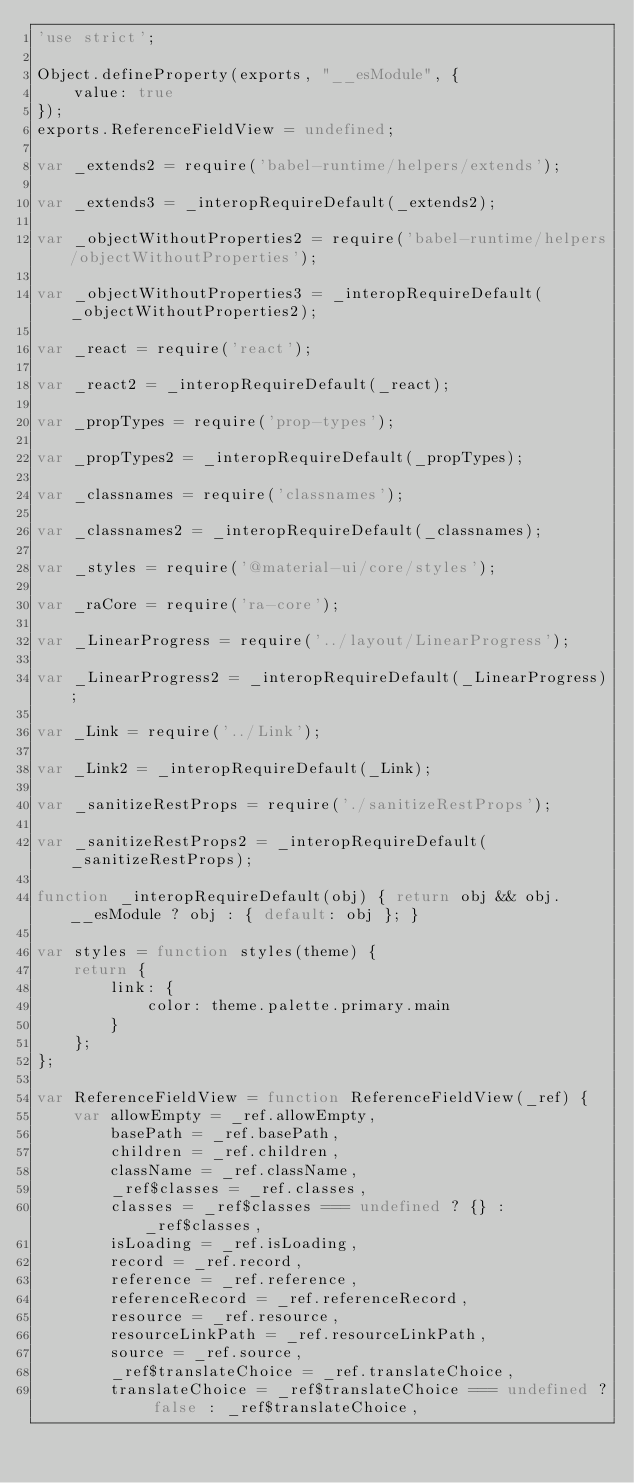Convert code to text. <code><loc_0><loc_0><loc_500><loc_500><_JavaScript_>'use strict';

Object.defineProperty(exports, "__esModule", {
    value: true
});
exports.ReferenceFieldView = undefined;

var _extends2 = require('babel-runtime/helpers/extends');

var _extends3 = _interopRequireDefault(_extends2);

var _objectWithoutProperties2 = require('babel-runtime/helpers/objectWithoutProperties');

var _objectWithoutProperties3 = _interopRequireDefault(_objectWithoutProperties2);

var _react = require('react');

var _react2 = _interopRequireDefault(_react);

var _propTypes = require('prop-types');

var _propTypes2 = _interopRequireDefault(_propTypes);

var _classnames = require('classnames');

var _classnames2 = _interopRequireDefault(_classnames);

var _styles = require('@material-ui/core/styles');

var _raCore = require('ra-core');

var _LinearProgress = require('../layout/LinearProgress');

var _LinearProgress2 = _interopRequireDefault(_LinearProgress);

var _Link = require('../Link');

var _Link2 = _interopRequireDefault(_Link);

var _sanitizeRestProps = require('./sanitizeRestProps');

var _sanitizeRestProps2 = _interopRequireDefault(_sanitizeRestProps);

function _interopRequireDefault(obj) { return obj && obj.__esModule ? obj : { default: obj }; }

var styles = function styles(theme) {
    return {
        link: {
            color: theme.palette.primary.main
        }
    };
};

var ReferenceFieldView = function ReferenceFieldView(_ref) {
    var allowEmpty = _ref.allowEmpty,
        basePath = _ref.basePath,
        children = _ref.children,
        className = _ref.className,
        _ref$classes = _ref.classes,
        classes = _ref$classes === undefined ? {} : _ref$classes,
        isLoading = _ref.isLoading,
        record = _ref.record,
        reference = _ref.reference,
        referenceRecord = _ref.referenceRecord,
        resource = _ref.resource,
        resourceLinkPath = _ref.resourceLinkPath,
        source = _ref.source,
        _ref$translateChoice = _ref.translateChoice,
        translateChoice = _ref$translateChoice === undefined ? false : _ref$translateChoice,</code> 